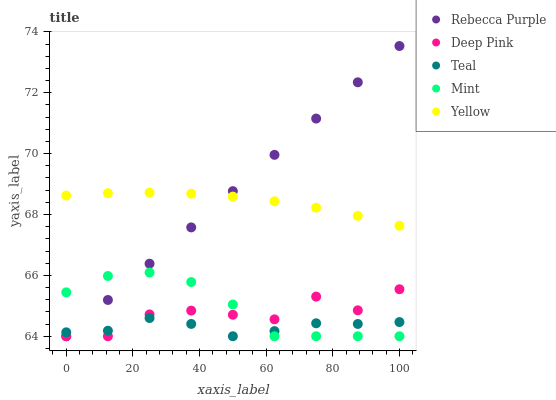Does Teal have the minimum area under the curve?
Answer yes or no. Yes. Does Rebecca Purple have the maximum area under the curve?
Answer yes or no. Yes. Does Deep Pink have the minimum area under the curve?
Answer yes or no. No. Does Deep Pink have the maximum area under the curve?
Answer yes or no. No. Is Rebecca Purple the smoothest?
Answer yes or no. Yes. Is Deep Pink the roughest?
Answer yes or no. Yes. Is Mint the smoothest?
Answer yes or no. No. Is Mint the roughest?
Answer yes or no. No. Does Deep Pink have the lowest value?
Answer yes or no. Yes. Does Rebecca Purple have the highest value?
Answer yes or no. Yes. Does Deep Pink have the highest value?
Answer yes or no. No. Is Mint less than Yellow?
Answer yes or no. Yes. Is Yellow greater than Deep Pink?
Answer yes or no. Yes. Does Teal intersect Mint?
Answer yes or no. Yes. Is Teal less than Mint?
Answer yes or no. No. Is Teal greater than Mint?
Answer yes or no. No. Does Mint intersect Yellow?
Answer yes or no. No. 